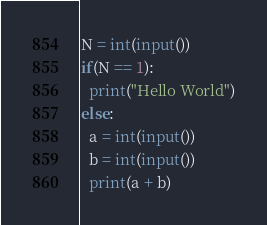<code> <loc_0><loc_0><loc_500><loc_500><_Python_>N = int(input())
if(N == 1):
  print("Hello World")
else:
  a = int(input())
  b = int(input())
  print(a + b)</code> 